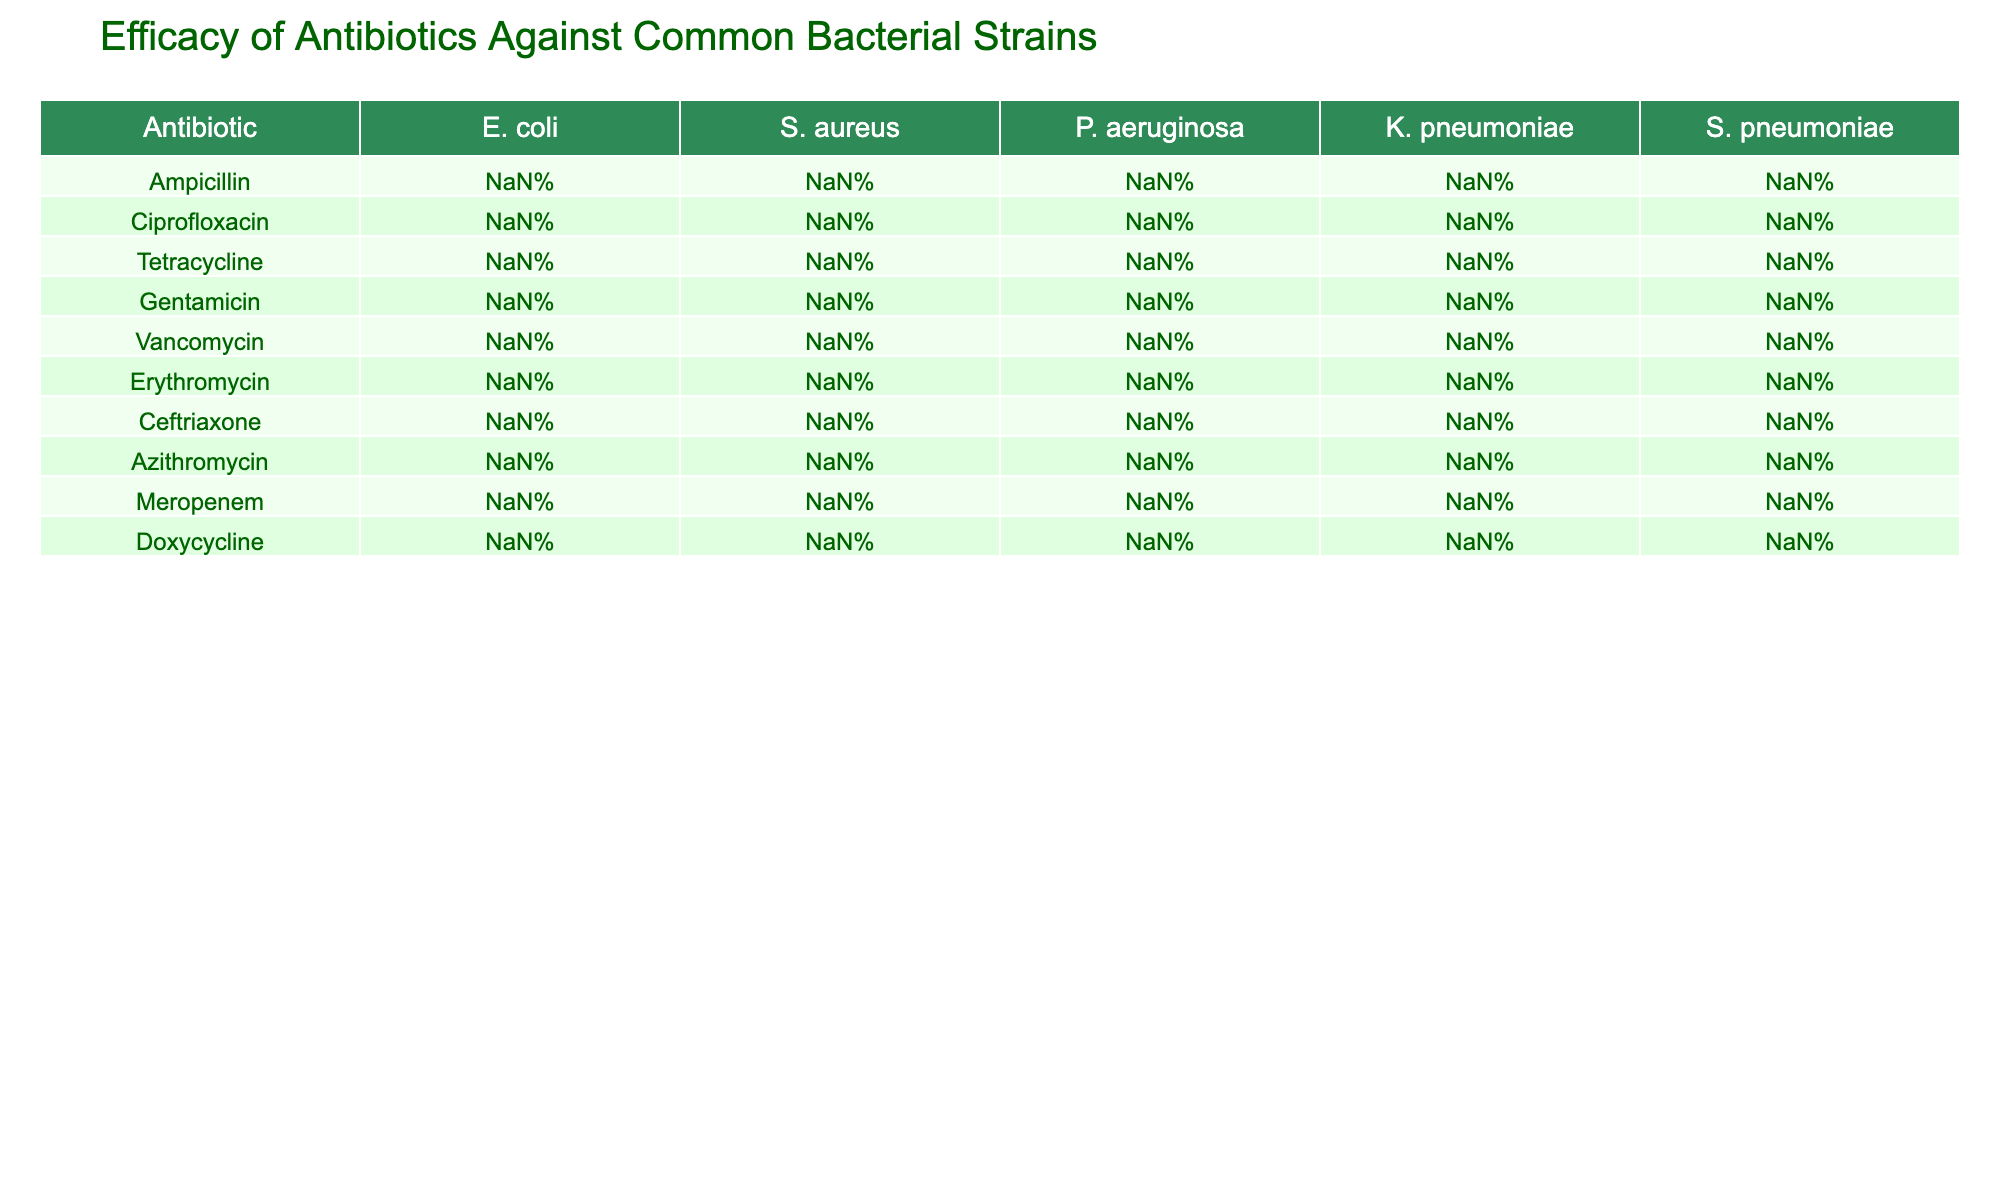What is the efficacy of Meropenem against S. aureus? The table shows Meropenem has an efficacy of 90% against S. aureus.
Answer: 90% Which antibiotic has the lowest efficacy against P. aeruginosa? According to the table, Vancomycin has 0% efficacy against P. aeruginosa, which is the lowest of all antibiotics listed.
Answer: Vancomycin What is the average efficacy of Ciprofloxacin across all bacterial strains? The efficacy percentages for Ciprofloxacin are: E. coli (95%), S. aureus (80%), P. aeruginosa (75%), K. pneumoniae (85%), S. pneumoniae (70%). Summing these gives 95 + 80 + 75 + 85 + 70 = 405. There are 5 data points, so the average is 405 / 5 = 81%.
Answer: 81% Is it true that Erythromycin is more effective against S. pneumoniae than Gentamicin? The table shows Erythromycin has 90% efficacy against S. pneumoniae while Gentamicin has 40%. Therefore, the statement is true.
Answer: Yes Which antibiotic has the highest efficacy against K. pneumoniae? The table lists Meropenem with an efficacy of 95% as the highest against K. pneumoniae compared to other antibiotics.
Answer: Meropenem What is the difference in efficacy between Gentamicin and Tetracycline against E. coli? The efficacy of Gentamicin against E. coli is 90% and for Tetracycline, it is 70%. The difference is calculated as 90% - 70% = 20%.
Answer: 20% Which antibiotic has a higher efficacy against S. aureus, Ampicillin or Doxycycline? The table indicates Ampicillin has 45% efficacy against S. aureus, while Doxycycline has 70%. Therefore, Doxycycline is higher.
Answer: Doxycycline What is the median efficacy of antibiotics against E. coli? The efficacies for E. coli are: 85%, 95%, 70%, 90%, 5%, 40%, 95%, 50%, 99%, 75%. Arranging these in order gives: 5%, 40%, 50%, 70%, 75%, 85%, 90%, 95%, 95%, 99%. The median, which is the average of the 5th and 6th values (75% and 85%), is (75% + 85%) / 2 = 80%.
Answer: 80% Which antibiotic is most effective overall, considering the highest efficacy against each bacterial strain? By analyzing the highest efficacies in the table: E. coli - Meropenem (99%), S. aureus - Vancomycin (95%), P. aeruginosa - Meropenem (85%), K. pneumoniae - Meropenem (95%), S. pneumoniae - Vancomycin (99%). Meropenem has the highest overall efficacy against 3 strains.
Answer: Meropenem Does Azithromycin have better efficacy against S. pneumoniae than Tetracycline? The efficacy of Azithromycin against S. pneumoniae is 92% and Tetracycline is 80%. Thus, Azithromycin has better efficacy.
Answer: Yes 